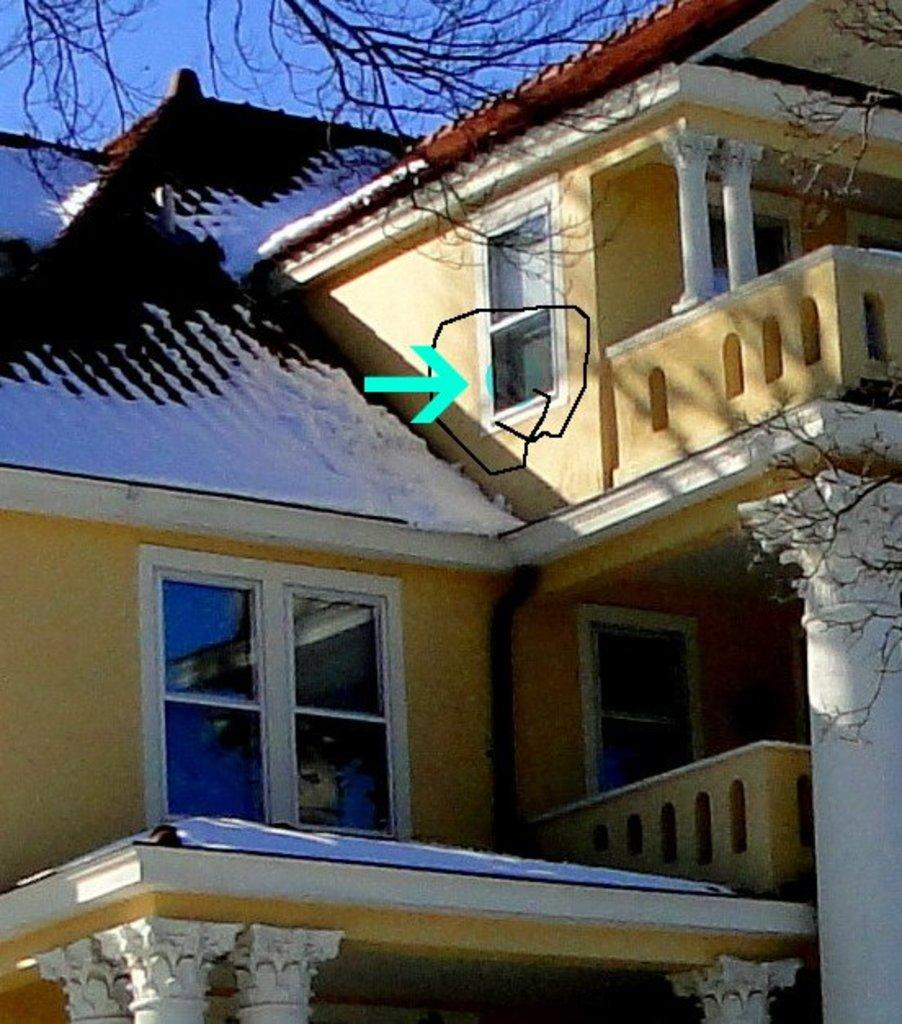What type of structure is present in the image? There is a house in the image. What feature can be seen on the house? The house has windows. Is there any additional marking on the house? Yes, there is an arrow mark on top of the house. What type of vegetation is present in the image? There is a tree on the right side of the image and another tree in the top left corner of the image. What type of lace is used to decorate the windows of the house in the image? There is no mention of lace or any decorative elements on the windows in the image. 